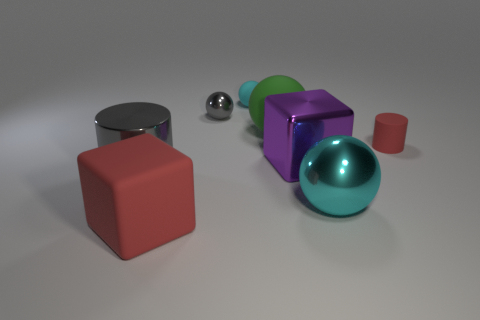Subtract all cyan balls. How many were subtracted if there are1cyan balls left? 1 Subtract 1 balls. How many balls are left? 3 Add 1 metal spheres. How many objects exist? 9 Subtract all cubes. How many objects are left? 6 Add 1 cyan metal balls. How many cyan metal balls exist? 2 Subtract 0 red balls. How many objects are left? 8 Subtract all big spheres. Subtract all big green balls. How many objects are left? 5 Add 4 large gray objects. How many large gray objects are left? 5 